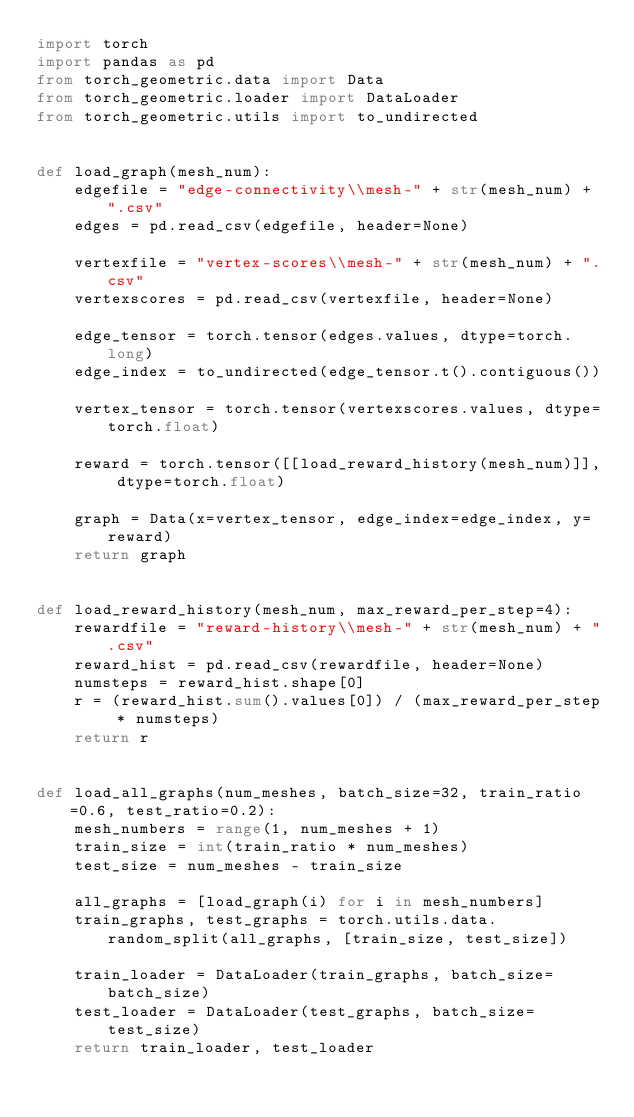Convert code to text. <code><loc_0><loc_0><loc_500><loc_500><_Python_>import torch
import pandas as pd
from torch_geometric.data import Data
from torch_geometric.loader import DataLoader
from torch_geometric.utils import to_undirected


def load_graph(mesh_num):
    edgefile = "edge-connectivity\\mesh-" + str(mesh_num) + ".csv"
    edges = pd.read_csv(edgefile, header=None)

    vertexfile = "vertex-scores\\mesh-" + str(mesh_num) + ".csv"
    vertexscores = pd.read_csv(vertexfile, header=None)

    edge_tensor = torch.tensor(edges.values, dtype=torch.long)
    edge_index = to_undirected(edge_tensor.t().contiguous())

    vertex_tensor = torch.tensor(vertexscores.values, dtype=torch.float)

    reward = torch.tensor([[load_reward_history(mesh_num)]], dtype=torch.float)

    graph = Data(x=vertex_tensor, edge_index=edge_index, y=reward)
    return graph


def load_reward_history(mesh_num, max_reward_per_step=4):
    rewardfile = "reward-history\\mesh-" + str(mesh_num) + ".csv"
    reward_hist = pd.read_csv(rewardfile, header=None)
    numsteps = reward_hist.shape[0]
    r = (reward_hist.sum().values[0]) / (max_reward_per_step * numsteps)
    return r


def load_all_graphs(num_meshes, batch_size=32, train_ratio=0.6, test_ratio=0.2):
    mesh_numbers = range(1, num_meshes + 1)
    train_size = int(train_ratio * num_meshes)
    test_size = num_meshes - train_size

    all_graphs = [load_graph(i) for i in mesh_numbers]
    train_graphs, test_graphs = torch.utils.data.random_split(all_graphs, [train_size, test_size])

    train_loader = DataLoader(train_graphs, batch_size=batch_size)
    test_loader = DataLoader(test_graphs, batch_size=test_size)
    return train_loader, test_loader
</code> 